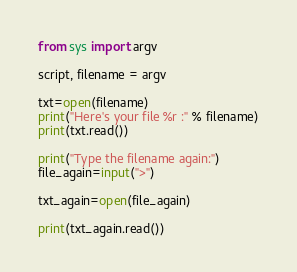<code> <loc_0><loc_0><loc_500><loc_500><_Python_>from sys import argv 

script, filename = argv

txt=open(filename)
print("Here's your file %r :" % filename)
print(txt.read())

print("Type the filename again:")
file_again=input(">")

txt_again=open(file_again)

print(txt_again.read())
</code> 